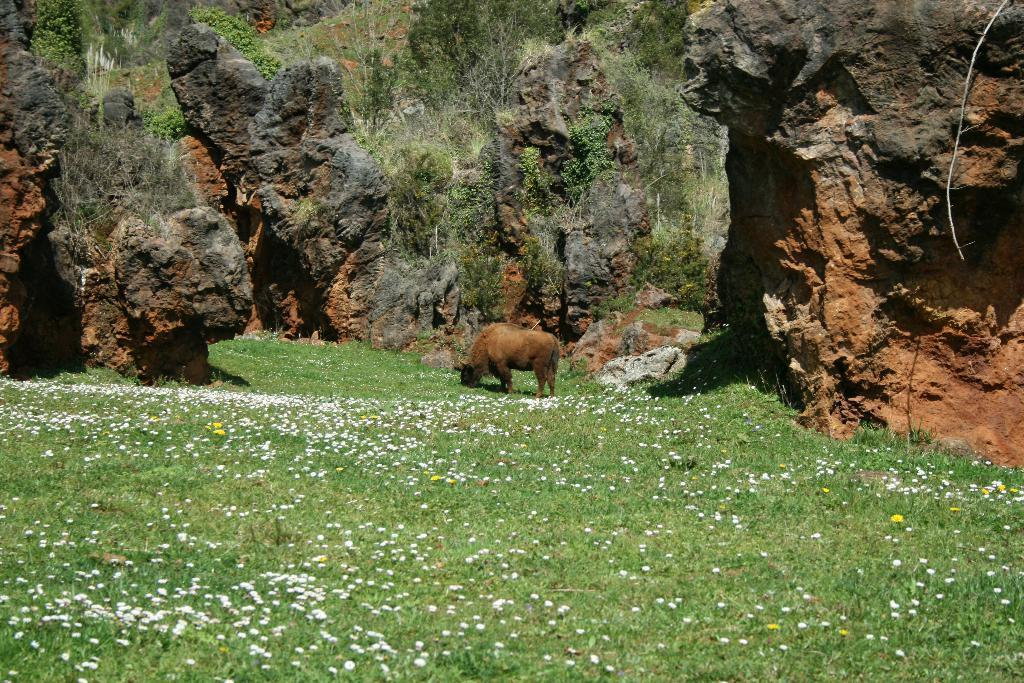What type of animal can be seen in the image? There is an animal in the image, but its specific type cannot be determined from the provided facts. What color is the animal in the image? The animal is brown in color. What type of vegetation is present in the image? There is grass, rocks, and plants in the image. What colors are the flowers in the image? There are white and yellow color flowers in the image. What type of shirt is the animal wearing in the image? There is no shirt present in the image, as animals do not wear clothing. Can you tell me how many chairs are visible in the image? There are no chairs present in the image. 